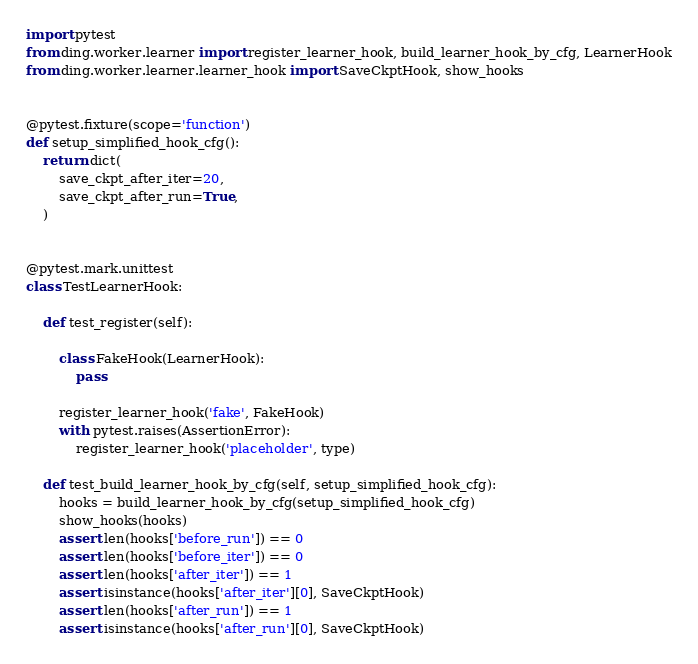Convert code to text. <code><loc_0><loc_0><loc_500><loc_500><_Python_>import pytest
from ding.worker.learner import register_learner_hook, build_learner_hook_by_cfg, LearnerHook
from ding.worker.learner.learner_hook import SaveCkptHook, show_hooks


@pytest.fixture(scope='function')
def setup_simplified_hook_cfg():
    return dict(
        save_ckpt_after_iter=20,
        save_ckpt_after_run=True,
    )


@pytest.mark.unittest
class TestLearnerHook:

    def test_register(self):

        class FakeHook(LearnerHook):
            pass

        register_learner_hook('fake', FakeHook)
        with pytest.raises(AssertionError):
            register_learner_hook('placeholder', type)

    def test_build_learner_hook_by_cfg(self, setup_simplified_hook_cfg):
        hooks = build_learner_hook_by_cfg(setup_simplified_hook_cfg)
        show_hooks(hooks)
        assert len(hooks['before_run']) == 0
        assert len(hooks['before_iter']) == 0
        assert len(hooks['after_iter']) == 1
        assert isinstance(hooks['after_iter'][0], SaveCkptHook)
        assert len(hooks['after_run']) == 1
        assert isinstance(hooks['after_run'][0], SaveCkptHook)
</code> 